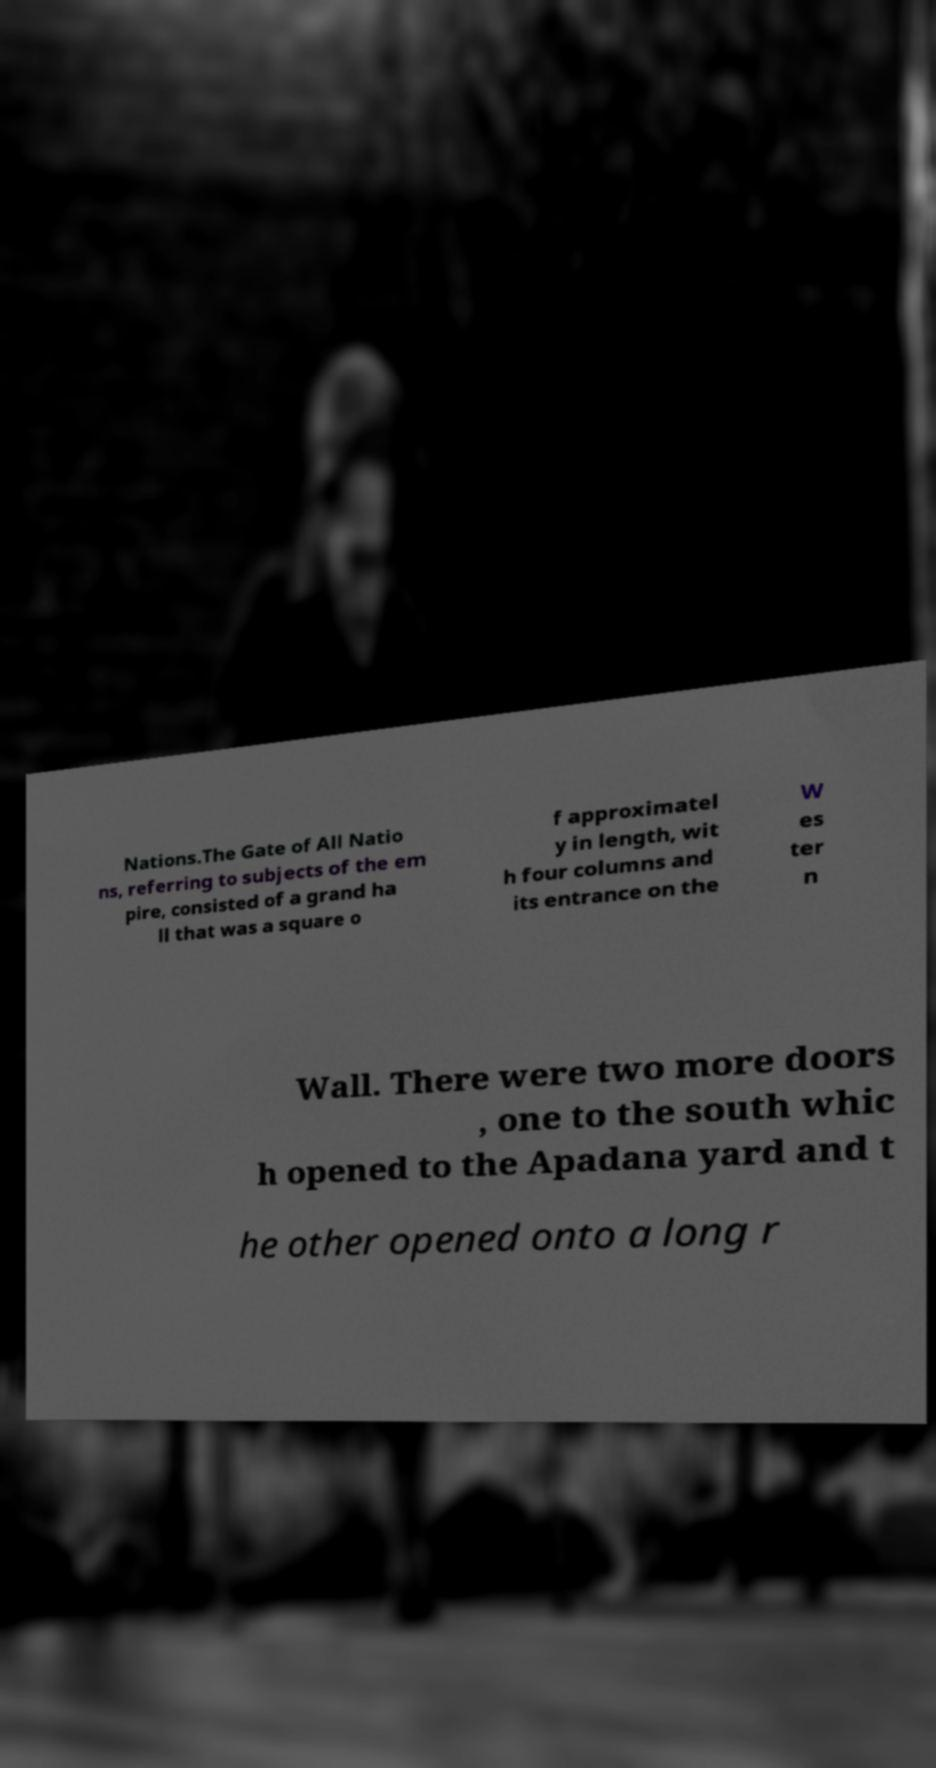I need the written content from this picture converted into text. Can you do that? Nations.The Gate of All Natio ns, referring to subjects of the em pire, consisted of a grand ha ll that was a square o f approximatel y in length, wit h four columns and its entrance on the W es ter n Wall. There were two more doors , one to the south whic h opened to the Apadana yard and t he other opened onto a long r 